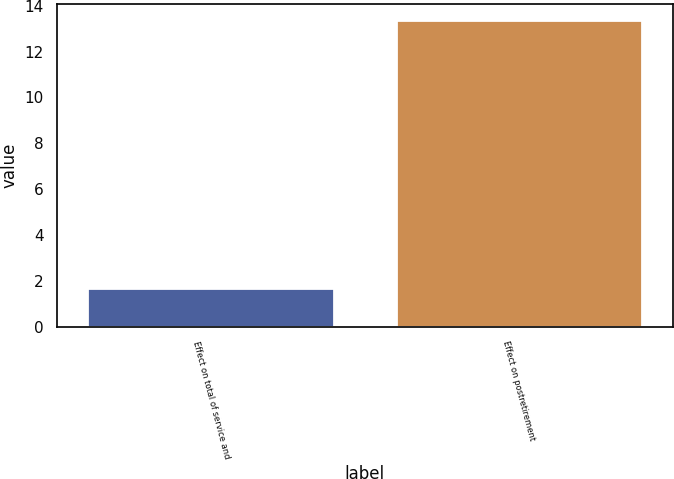Convert chart to OTSL. <chart><loc_0><loc_0><loc_500><loc_500><bar_chart><fcel>Effect on total of service and<fcel>Effect on postretirement<nl><fcel>1.7<fcel>13.4<nl></chart> 